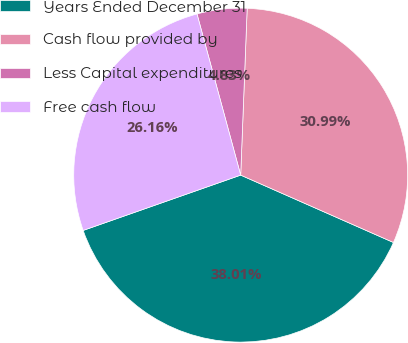Convert chart. <chart><loc_0><loc_0><loc_500><loc_500><pie_chart><fcel>Years Ended December 31<fcel>Cash flow provided by<fcel>Less Capital expenditures<fcel>Free cash flow<nl><fcel>38.01%<fcel>30.99%<fcel>4.83%<fcel>26.16%<nl></chart> 